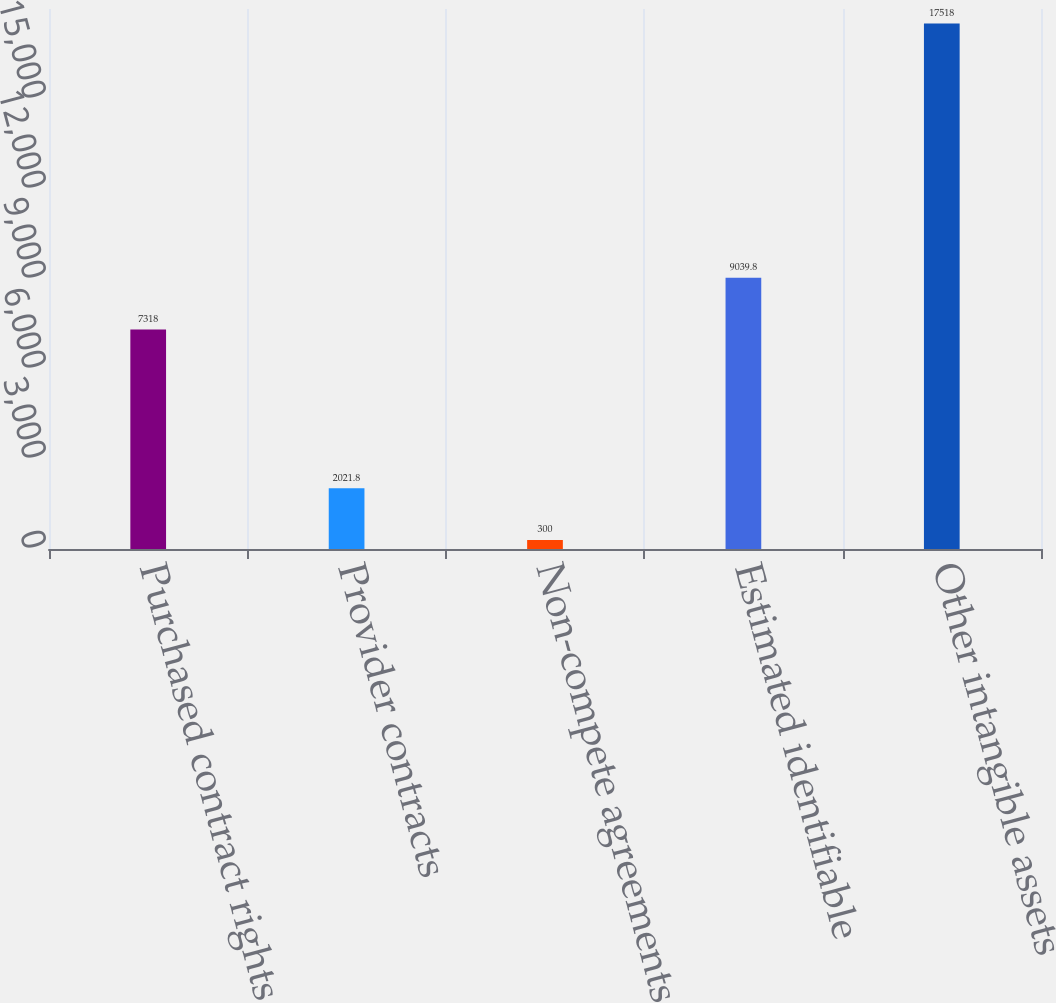Convert chart. <chart><loc_0><loc_0><loc_500><loc_500><bar_chart><fcel>Purchased contract rights<fcel>Provider contracts<fcel>Non-compete agreements<fcel>Estimated identifiable<fcel>Other intangible assets<nl><fcel>7318<fcel>2021.8<fcel>300<fcel>9039.8<fcel>17518<nl></chart> 